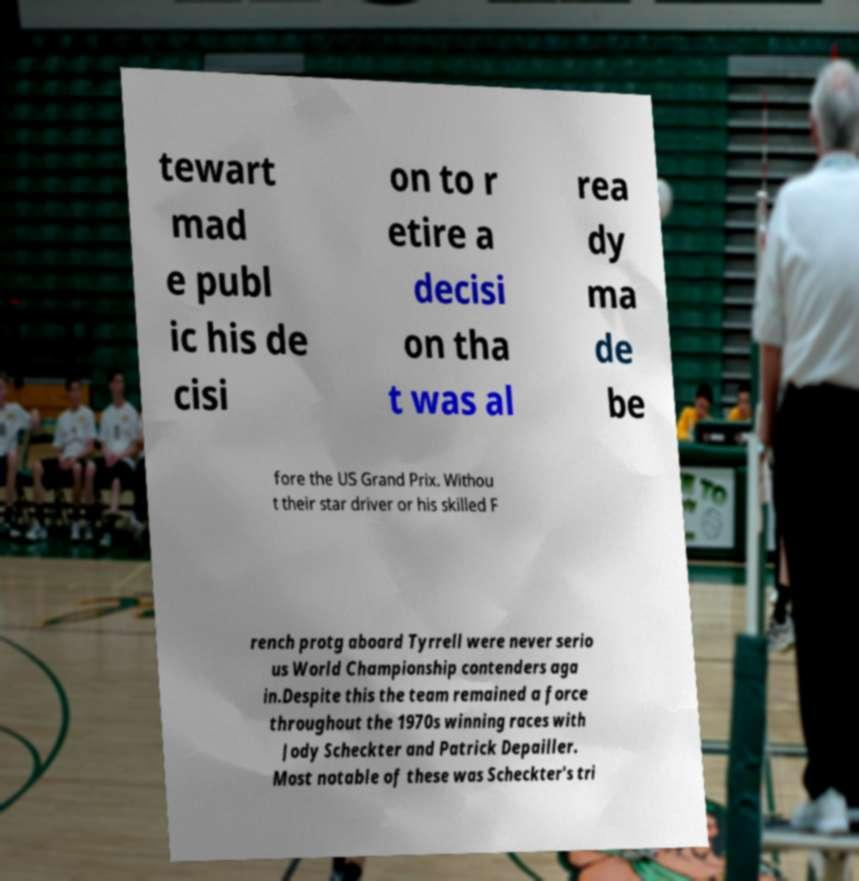For documentation purposes, I need the text within this image transcribed. Could you provide that? tewart mad e publ ic his de cisi on to r etire a decisi on tha t was al rea dy ma de be fore the US Grand Prix. Withou t their star driver or his skilled F rench protg aboard Tyrrell were never serio us World Championship contenders aga in.Despite this the team remained a force throughout the 1970s winning races with Jody Scheckter and Patrick Depailler. Most notable of these was Scheckter's tri 